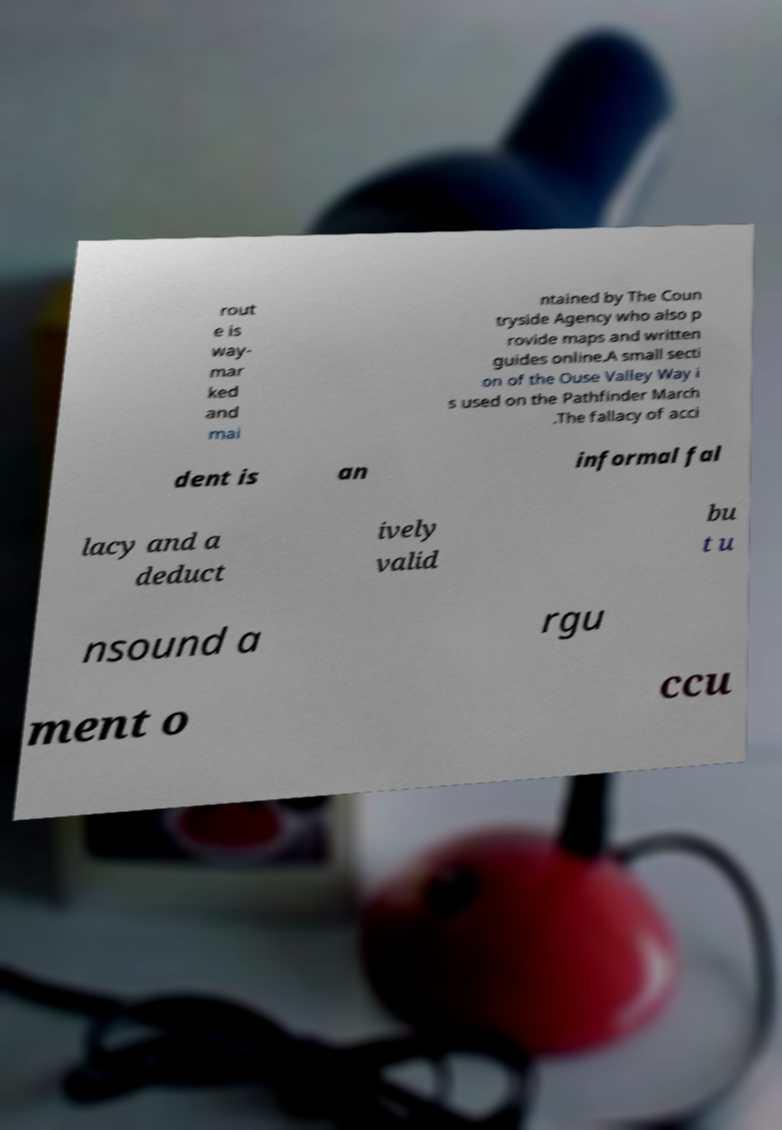Can you accurately transcribe the text from the provided image for me? rout e is way- mar ked and mai ntained by The Coun tryside Agency who also p rovide maps and written guides online.A small secti on of the Ouse Valley Way i s used on the Pathfinder March .The fallacy of acci dent is an informal fal lacy and a deduct ively valid bu t u nsound a rgu ment o ccu 